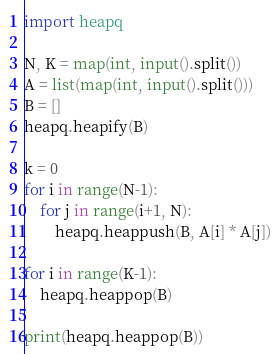<code> <loc_0><loc_0><loc_500><loc_500><_Python_>import heapq

N, K = map(int, input().split())
A = list(map(int, input().split()))
B = []
heapq.heapify(B)

k = 0
for i in range(N-1):
    for j in range(i+1, N):
        heapq.heappush(B, A[i] * A[j])

for i in range(K-1):
    heapq.heappop(B)

print(heapq.heappop(B))
</code> 